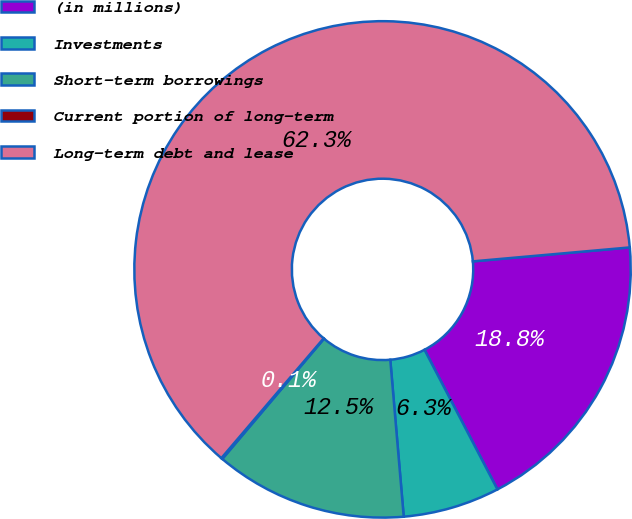Convert chart to OTSL. <chart><loc_0><loc_0><loc_500><loc_500><pie_chart><fcel>(in millions)<fcel>Investments<fcel>Short-term borrowings<fcel>Current portion of long-term<fcel>Long-term debt and lease<nl><fcel>18.75%<fcel>6.3%<fcel>12.53%<fcel>0.08%<fcel>62.34%<nl></chart> 